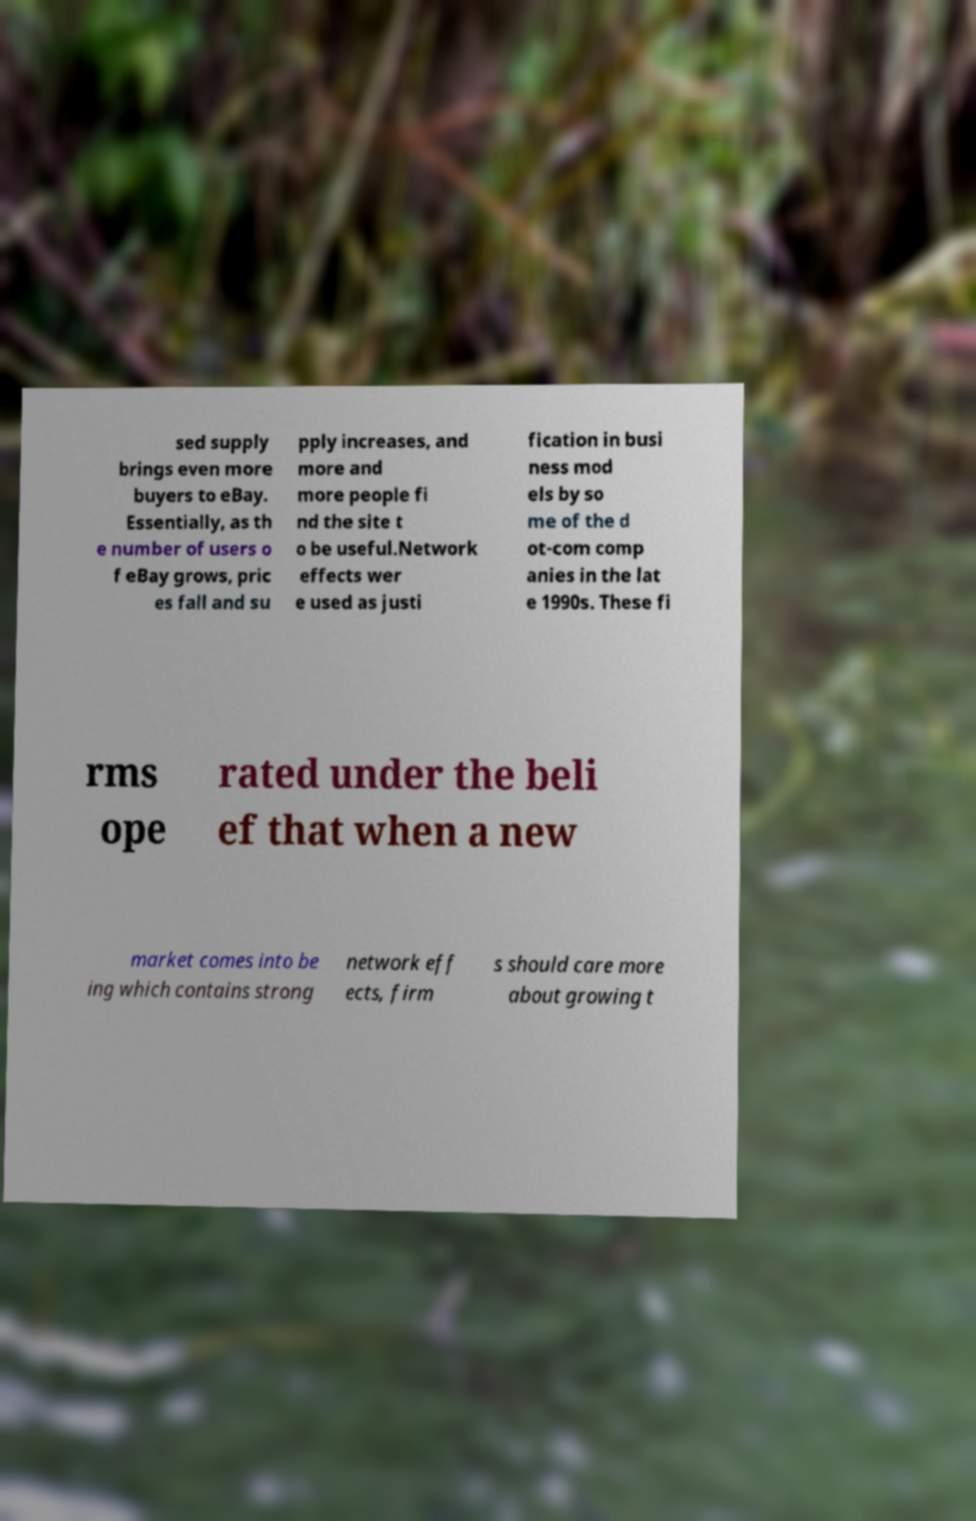Can you accurately transcribe the text from the provided image for me? sed supply brings even more buyers to eBay. Essentially, as th e number of users o f eBay grows, pric es fall and su pply increases, and more and more people fi nd the site t o be useful.Network effects wer e used as justi fication in busi ness mod els by so me of the d ot-com comp anies in the lat e 1990s. These fi rms ope rated under the beli ef that when a new market comes into be ing which contains strong network eff ects, firm s should care more about growing t 